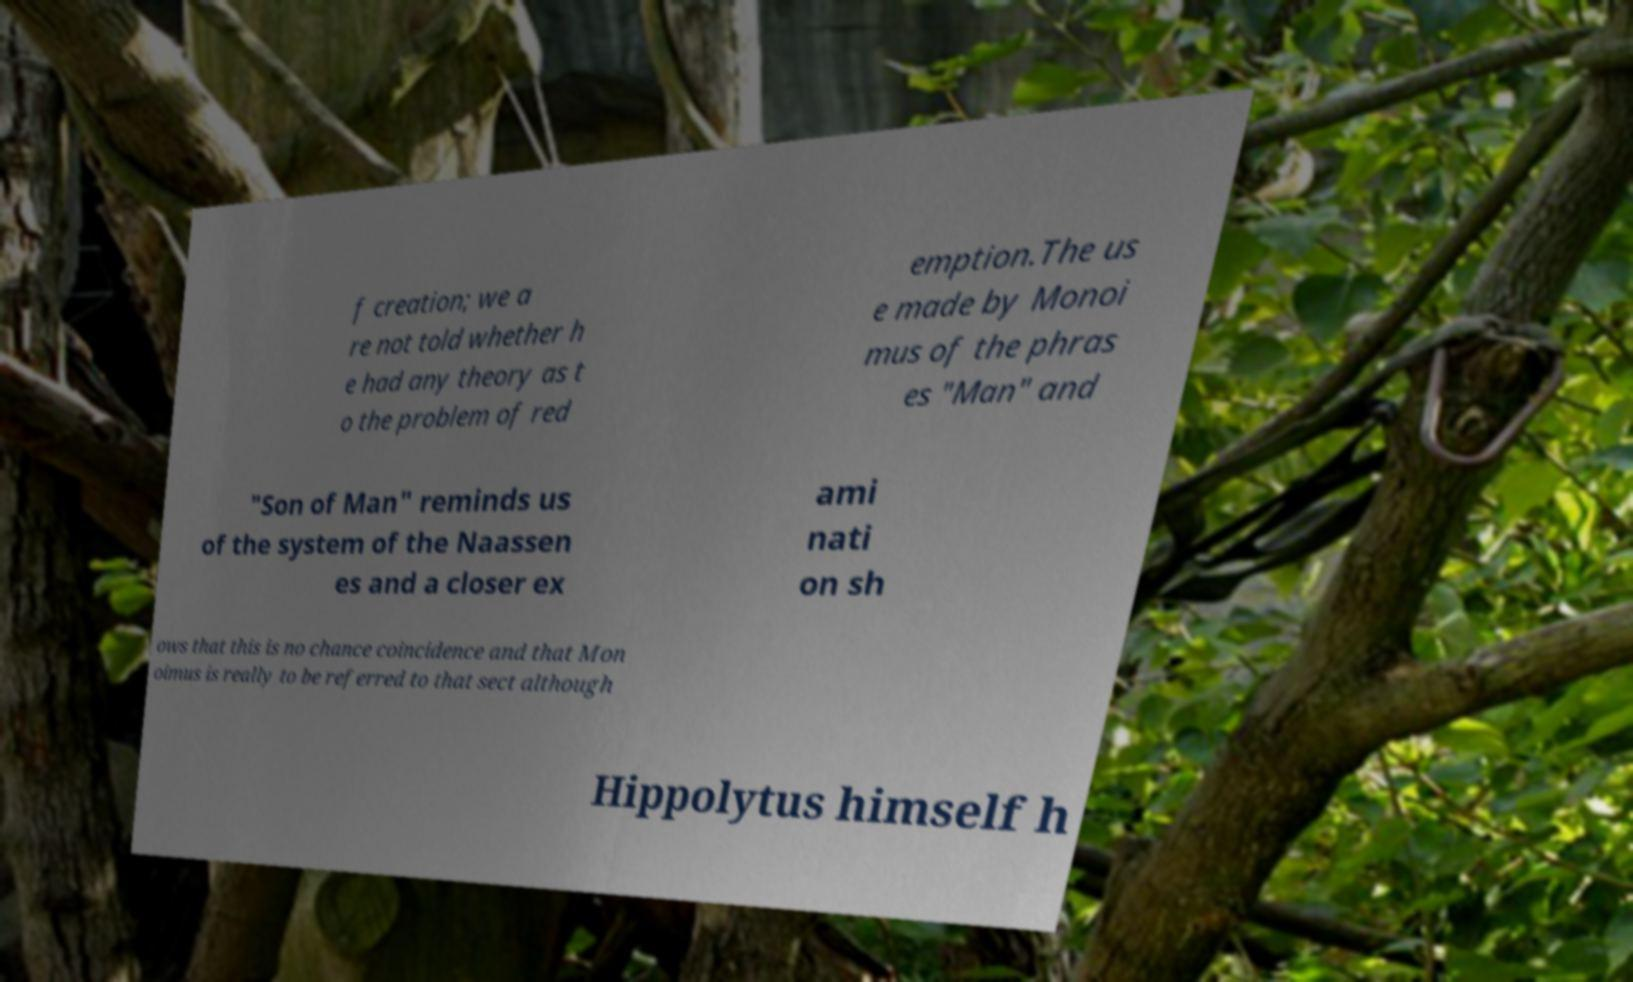Can you accurately transcribe the text from the provided image for me? f creation; we a re not told whether h e had any theory as t o the problem of red emption.The us e made by Monoi mus of the phras es "Man" and "Son of Man" reminds us of the system of the Naassen es and a closer ex ami nati on sh ows that this is no chance coincidence and that Mon oimus is really to be referred to that sect although Hippolytus himself h 